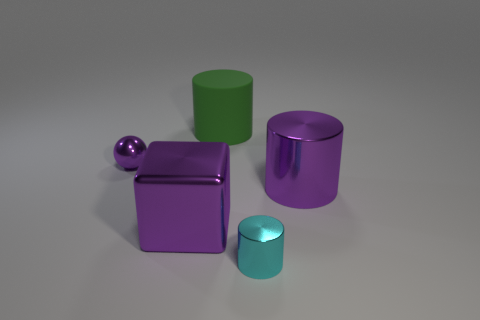Subtract all big cylinders. How many cylinders are left? 1 Add 3 tiny shiny cylinders. How many objects exist? 8 Subtract all green cylinders. How many cylinders are left? 2 Subtract 0 blue blocks. How many objects are left? 5 Subtract all balls. How many objects are left? 4 Subtract 1 cubes. How many cubes are left? 0 Subtract all brown balls. Subtract all cyan cubes. How many balls are left? 1 Subtract all brown cubes. How many blue cylinders are left? 0 Subtract all large matte things. Subtract all large purple metal cylinders. How many objects are left? 3 Add 3 big purple shiny blocks. How many big purple shiny blocks are left? 4 